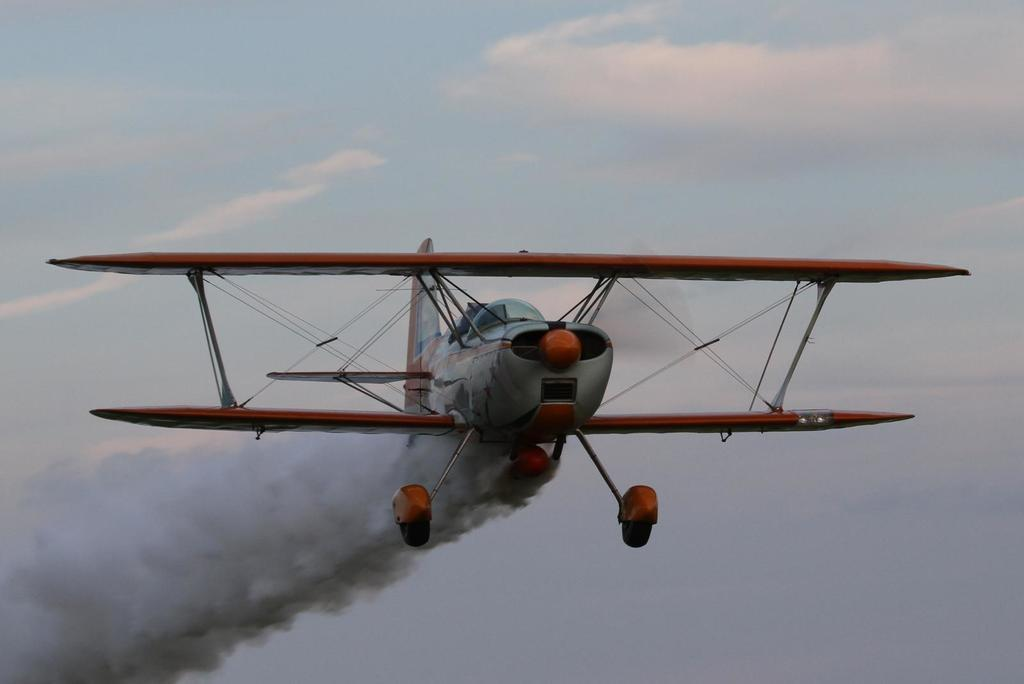Where was the picture taken? The picture was clicked outside. What can be seen in the sky in the image? There is an aircraft flying in the sky. What is the aircraft doing in the image? The aircraft appears to be releasing smoke. What is visible in the background of the image? The sky is visible in the background of the image. Are there any fairies visible in the image, using the smoke as bait? No, there are no fairies or any use of bait visible in the image. The image only shows an aircraft releasing smoke in the sky. 